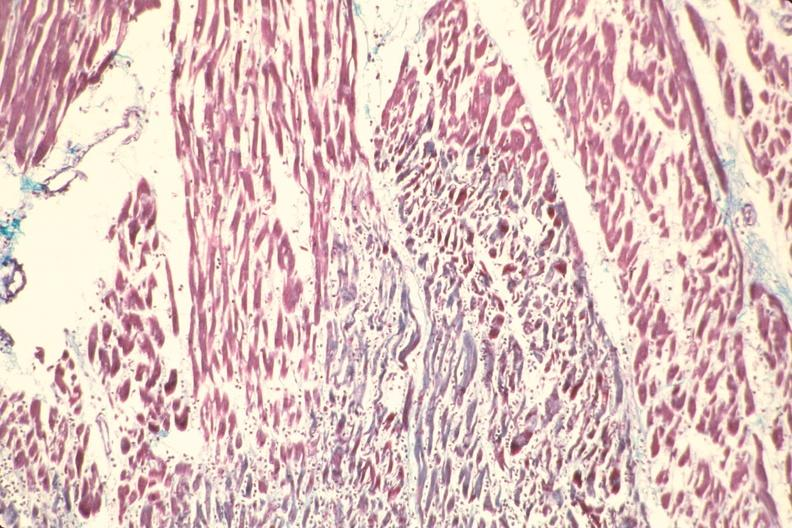where is this from?
Answer the question using a single word or phrase. Heart 